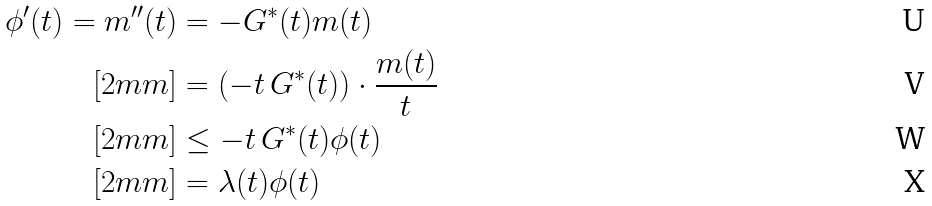<formula> <loc_0><loc_0><loc_500><loc_500>\phi ^ { \prime } ( t ) = m ^ { \prime \prime } ( t ) & = - G ^ { * } ( t ) m ( t ) \\ [ 2 m m ] & = \left ( - t \, G ^ { * } ( t ) \right ) \cdot \frac { m ( t ) } { t } \\ [ 2 m m ] & \leq - t \, G ^ { * } ( t ) \phi ( t ) \\ [ 2 m m ] & = \lambda ( t ) \phi ( t )</formula> 